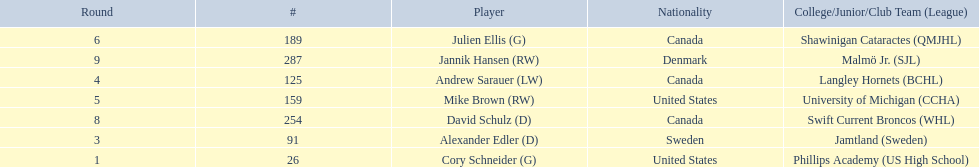Who are all the players? Cory Schneider (G), Alexander Edler (D), Andrew Sarauer (LW), Mike Brown (RW), Julien Ellis (G), David Schulz (D), Jannik Hansen (RW). What is the nationality of each player? United States, Sweden, Canada, United States, Canada, Canada, Denmark. Where did they attend school? Phillips Academy (US High School), Jamtland (Sweden), Langley Hornets (BCHL), University of Michigan (CCHA), Shawinigan Cataractes (QMJHL), Swift Current Broncos (WHL), Malmö Jr. (SJL). Which player attended langley hornets? Andrew Sarauer (LW). 